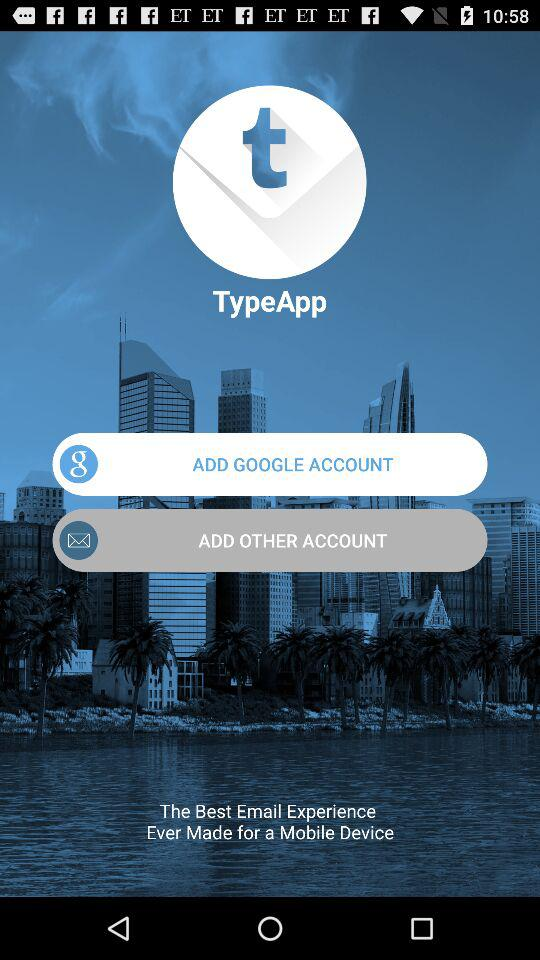What is the application name? The application name is "TypeApp". 